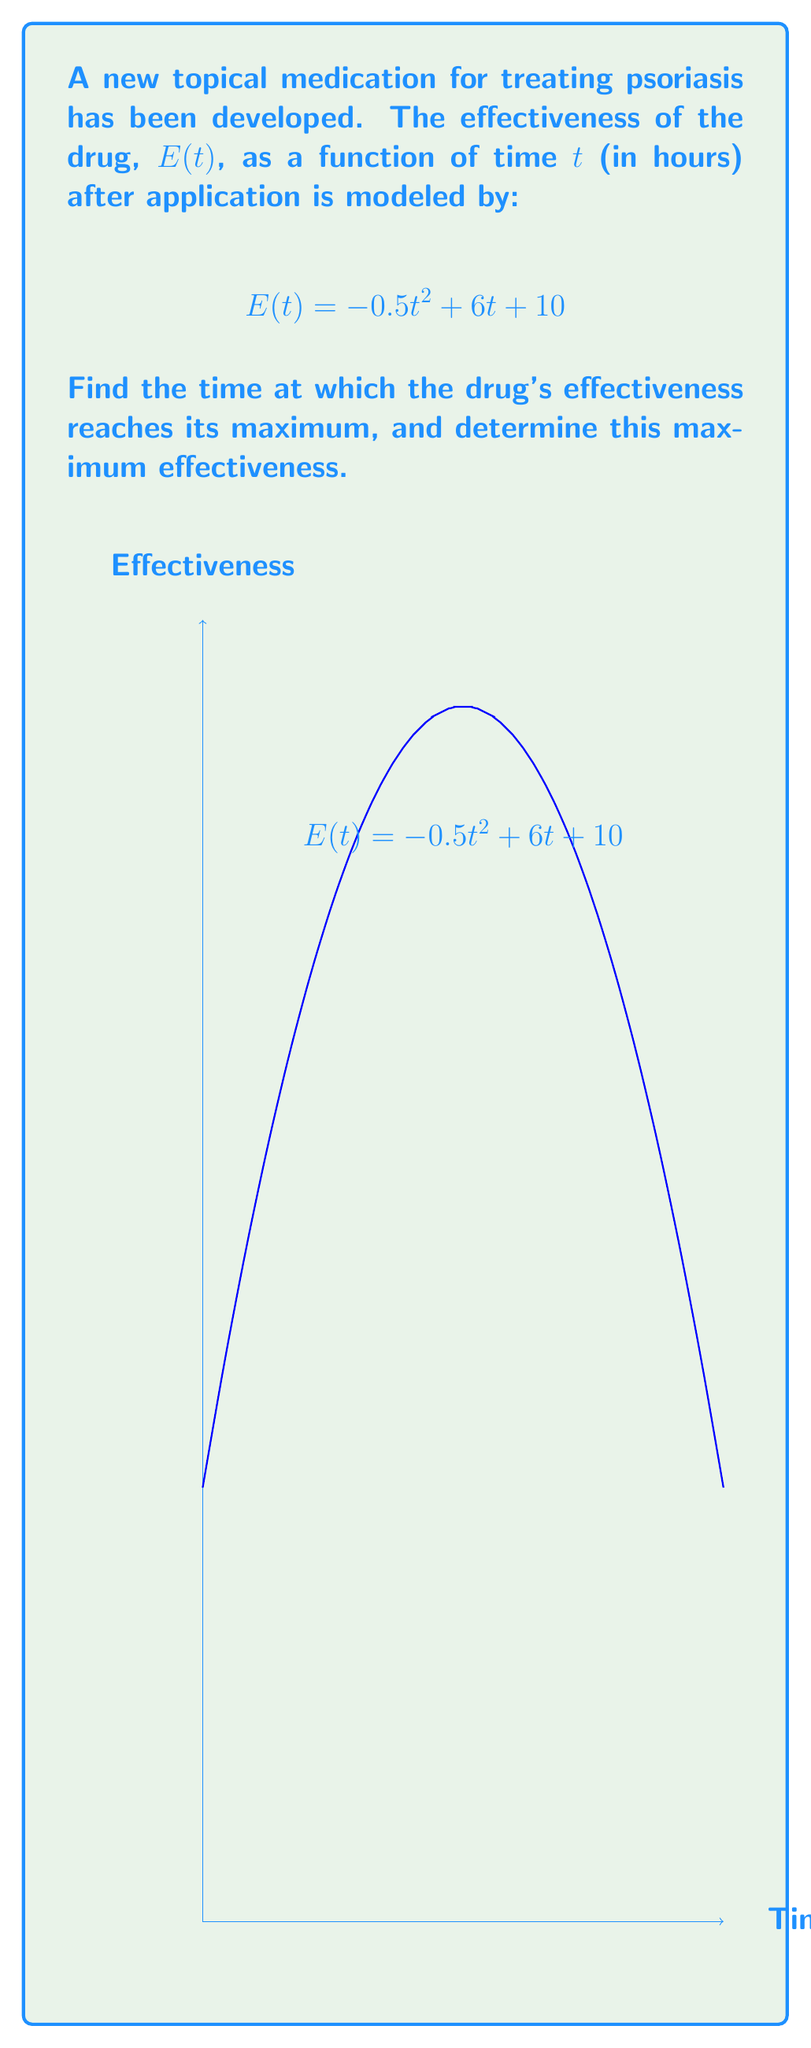Show me your answer to this math problem. To find the maximum effectiveness point, we need to follow these steps:

1) The maximum point occurs where the derivative of $E(t)$ is zero. Let's find $E'(t)$:

   $$E'(t) = -t + 6$$

2) Set $E'(t) = 0$ and solve for $t$:

   $$-t + 6 = 0$$
   $$t = 6$$

3) To confirm this is a maximum (not a minimum), we can check the second derivative:

   $$E''(t) = -1$$

   Since $E''(t)$ is negative, we confirm that $t = 6$ gives a maximum.

4) To find the maximum effectiveness, we substitute $t = 6$ into the original function:

   $$E(6) = -0.5(6)^2 + 6(6) + 10$$
   $$= -18 + 36 + 10$$
   $$= 28$$

Therefore, the drug's effectiveness reaches its maximum at $t = 6$ hours after application, with a maximum effectiveness of 28 units.
Answer: Maximum at $t = 6$ hours, $E(6) = 28$ units 